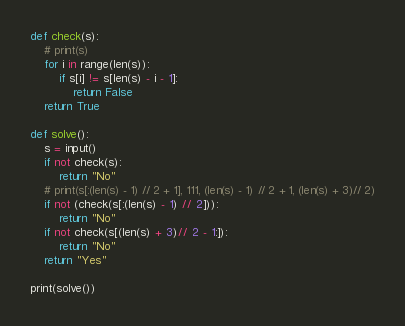<code> <loc_0><loc_0><loc_500><loc_500><_Python_>def check(s):
    # print(s)
    for i in range(len(s)):
        if s[i] != s[len(s) - i - 1]:
            return False
    return True

def solve():
    s = input()
    if not check(s):
        return "No"
    # print(s[:(len(s) - 1) // 2 + 1], 111, (len(s) - 1) // 2 + 1, (len(s) + 3)// 2)
    if not (check(s[:(len(s) - 1) // 2])):
        return "No"
    if not check(s[(len(s) + 3)// 2 - 1:]):
        return "No"
    return "Yes"

print(solve())</code> 